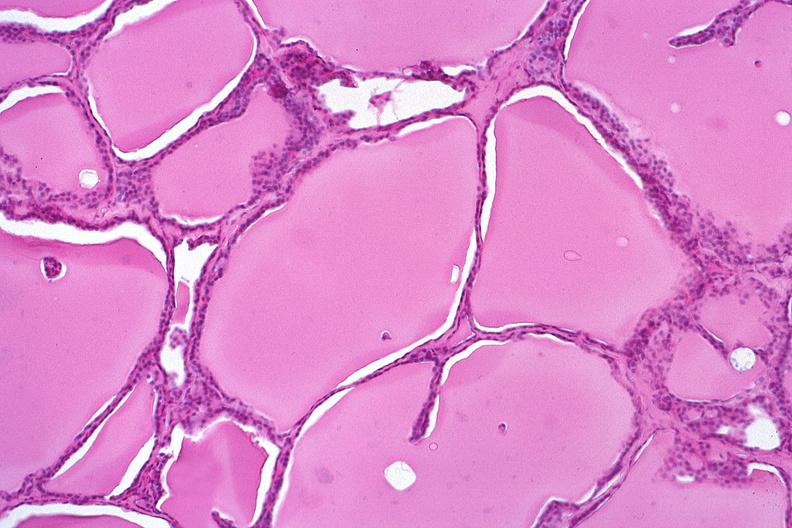does this image show thyroid, normal?
Answer the question using a single word or phrase. Yes 